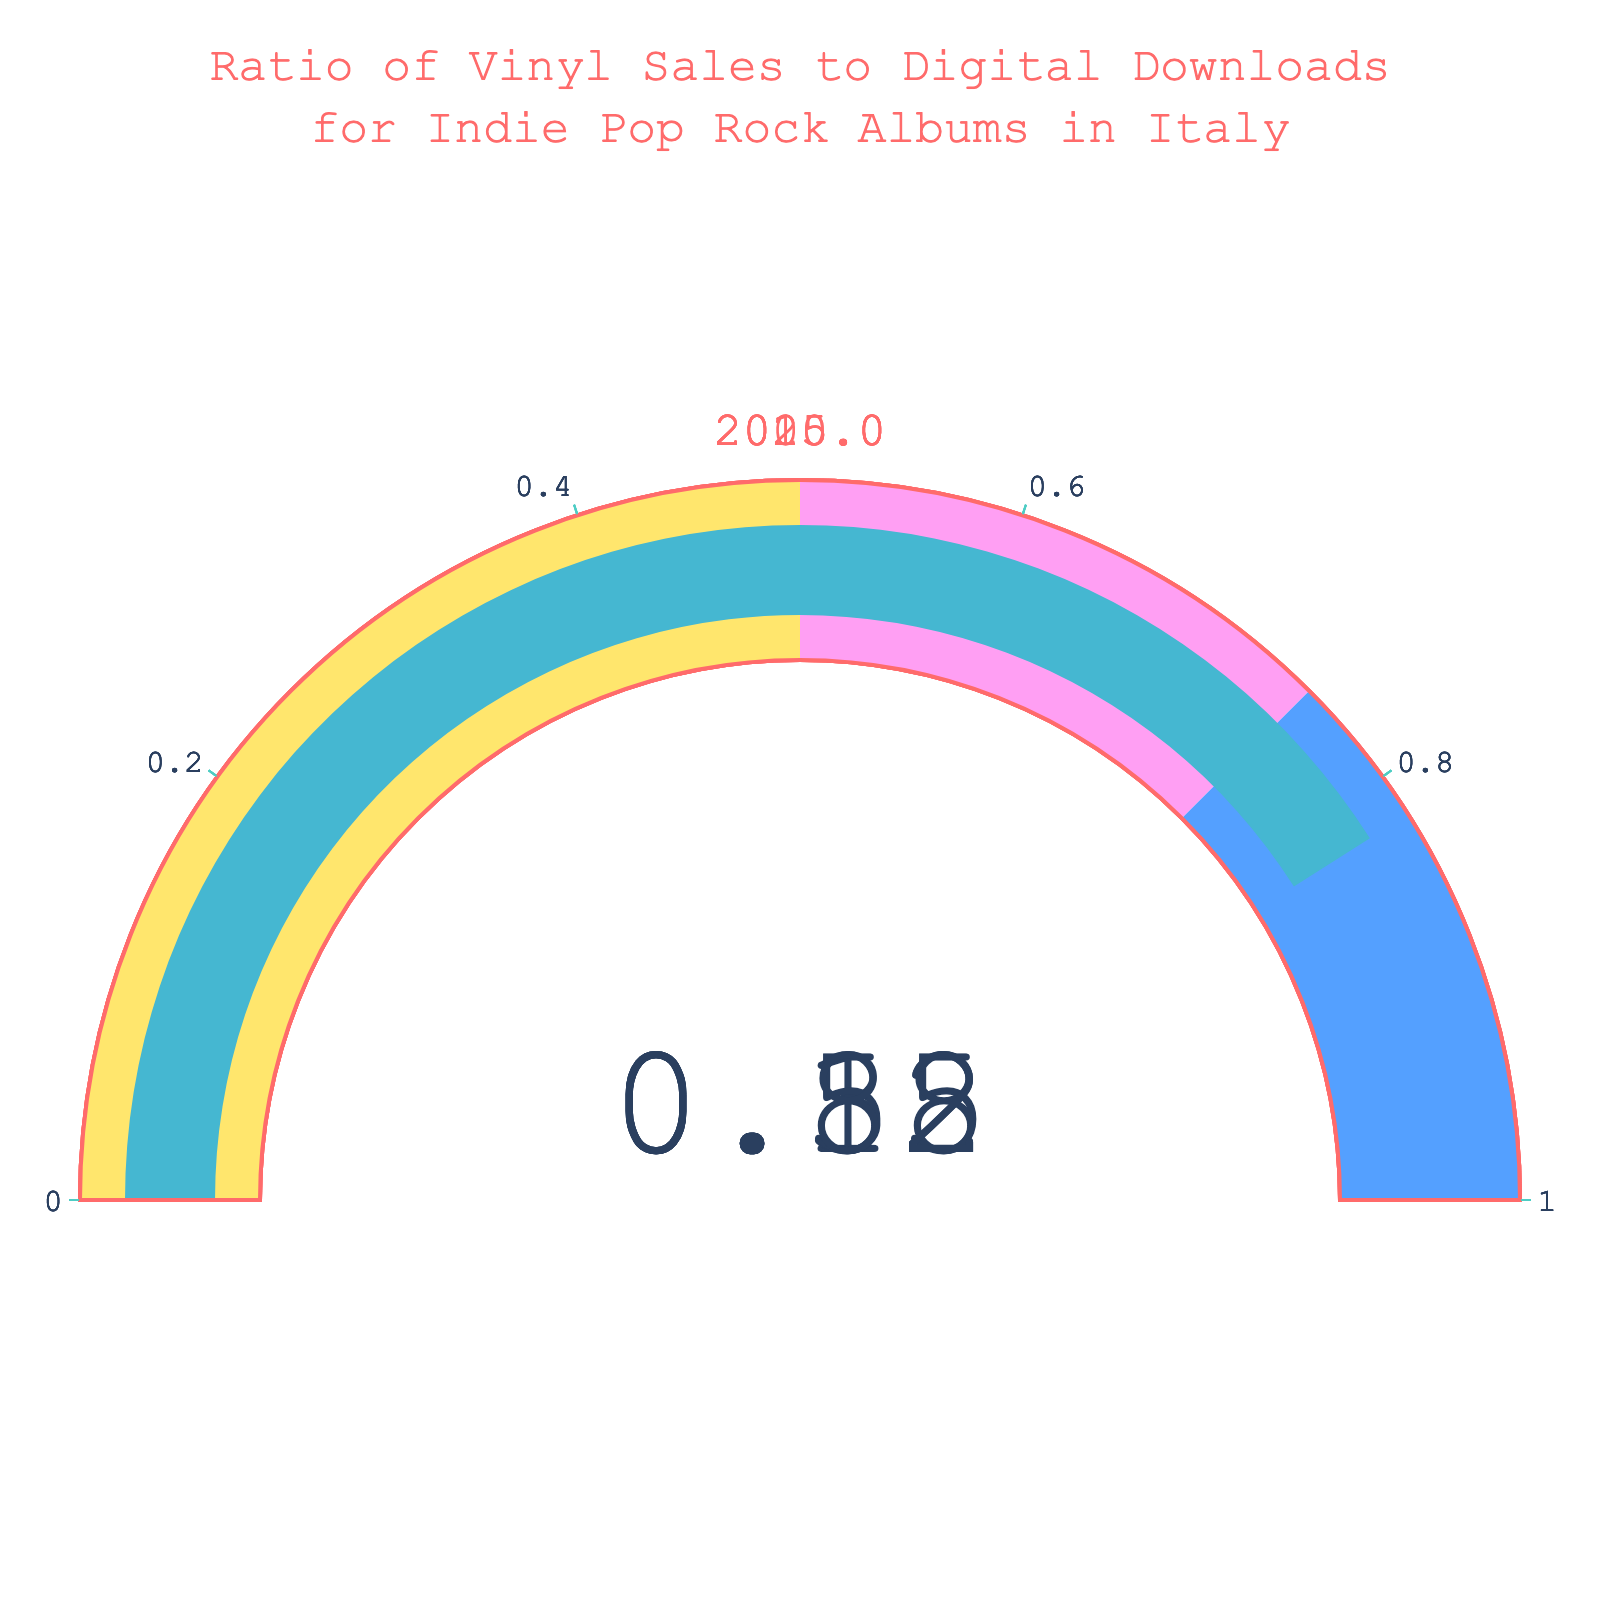What is the title of the figure? The figure displays the title at the top, "Ratio of Vinyl Sales to Digital Downloads for Indie Pop Rock Albums in Italy.”
Answer: Ratio of Vinyl Sales to Digital Downloads for Indie Pop Rock Albums in Italy How many years are represented in the figure? The figure has four distinct gauge charts with titles showing different years.
Answer: Four years Which year had the lowest ratio of vinyl sales to digital downloads? By looking at each gauge, the lowest ratio is in the year with a value of 0.12.
Answer: 2005 What is the ratio in the year 2015? The gauge chart labeled 2015 shows the ratio value.
Answer: 0.58 In which year did vinyl sales come closest to digital downloads? The year with the highest ratio value on the gauges is the year where the sales came closest to equaling downloads.
Answer: 2020 What's the average ratio over the four years? Sum all the ratios (0.12 + 0.35 + 0.58 + 0.82) and divide by the number of years (4).
Answer: 0.47 Which year had a ratio of more than twice the ratio seen in 2005? Calculate double the ratio of 2005 (2 * 0.12 = 0.24) and then find years with a ratio higher than that.
Answer: 2010, 2015, 2020 What is the difference in ratio between 2020 and 2005? Subtract the ratio of 2005 from the ratio of 2020 (0.82 - 0.12).
Answer: 0.70 